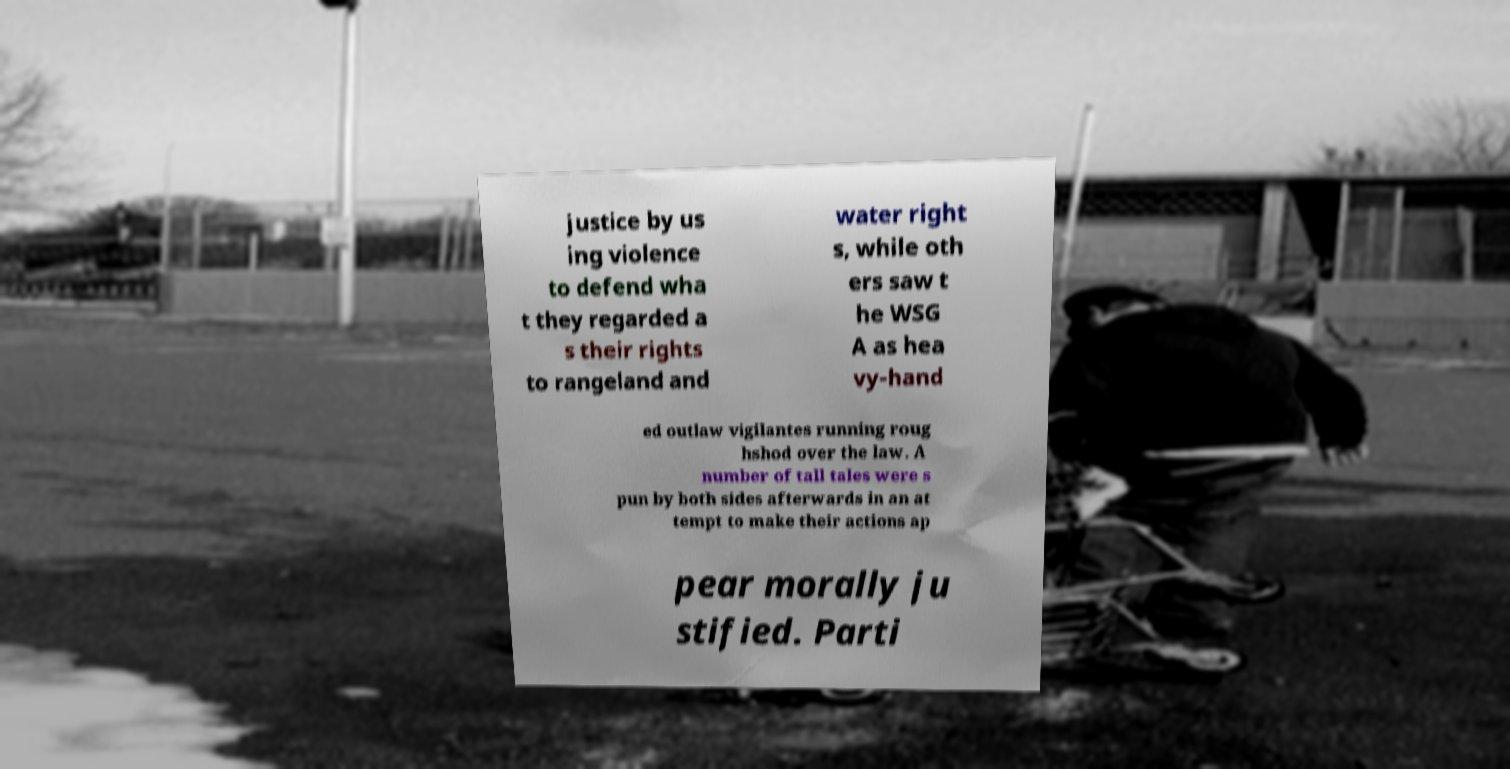Could you extract and type out the text from this image? justice by us ing violence to defend wha t they regarded a s their rights to rangeland and water right s, while oth ers saw t he WSG A as hea vy-hand ed outlaw vigilantes running roug hshod over the law. A number of tall tales were s pun by both sides afterwards in an at tempt to make their actions ap pear morally ju stified. Parti 